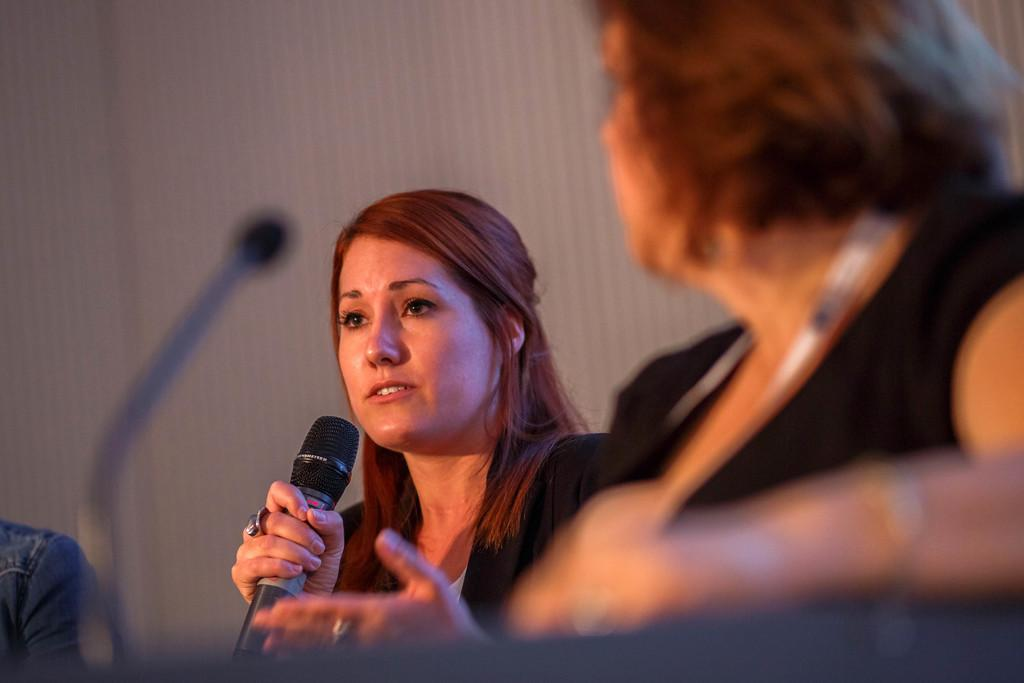How many women are seated in the image? There are two women seated on chairs in the image. What is one of the women doing in the image? One of the women is holding a microphone in her hand and speaking. Are there any men present in the image? Yes, there is a man present in the image. What type of bomb is the man holding in the image? There is no bomb present in the image; the man is not holding anything. 